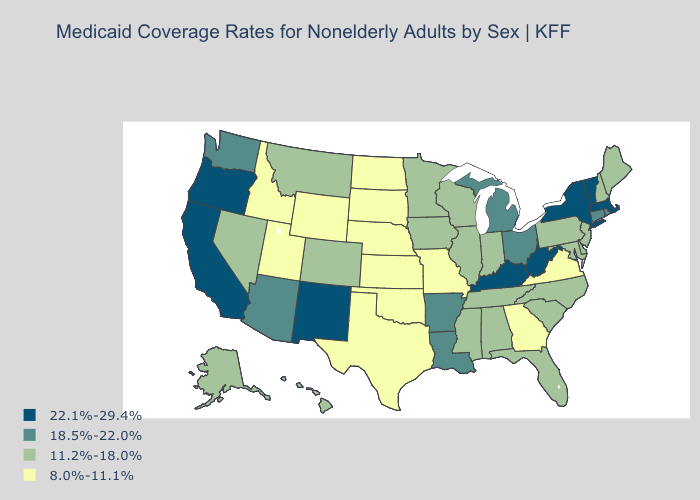Name the states that have a value in the range 22.1%-29.4%?
Answer briefly. California, Kentucky, Massachusetts, New Mexico, New York, Oregon, Vermont, West Virginia. What is the value of Illinois?
Answer briefly. 11.2%-18.0%. What is the lowest value in states that border Louisiana?
Give a very brief answer. 8.0%-11.1%. Does the map have missing data?
Concise answer only. No. What is the value of Connecticut?
Write a very short answer. 18.5%-22.0%. What is the value of Nevada?
Give a very brief answer. 11.2%-18.0%. Among the states that border Arkansas , does Mississippi have the highest value?
Keep it brief. No. What is the highest value in the USA?
Give a very brief answer. 22.1%-29.4%. Name the states that have a value in the range 22.1%-29.4%?
Give a very brief answer. California, Kentucky, Massachusetts, New Mexico, New York, Oregon, Vermont, West Virginia. Is the legend a continuous bar?
Concise answer only. No. Name the states that have a value in the range 8.0%-11.1%?
Concise answer only. Georgia, Idaho, Kansas, Missouri, Nebraska, North Dakota, Oklahoma, South Dakota, Texas, Utah, Virginia, Wyoming. Name the states that have a value in the range 8.0%-11.1%?
Answer briefly. Georgia, Idaho, Kansas, Missouri, Nebraska, North Dakota, Oklahoma, South Dakota, Texas, Utah, Virginia, Wyoming. How many symbols are there in the legend?
Answer briefly. 4. What is the value of Vermont?
Give a very brief answer. 22.1%-29.4%. Name the states that have a value in the range 18.5%-22.0%?
Be succinct. Arizona, Arkansas, Connecticut, Louisiana, Michigan, Ohio, Rhode Island, Washington. 